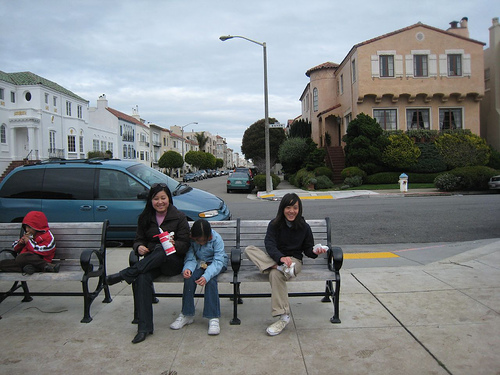What activity might the person on the left be doing? The individual on the left appears to be focused on a task that requires attention to their hands. It's possible they could be sorting through a bag, adjusting a piece of clothing, or even fiddling with a personal electronic device. The exact activity isn't clear from this angle, but it's definitely something that has caught their interest. 